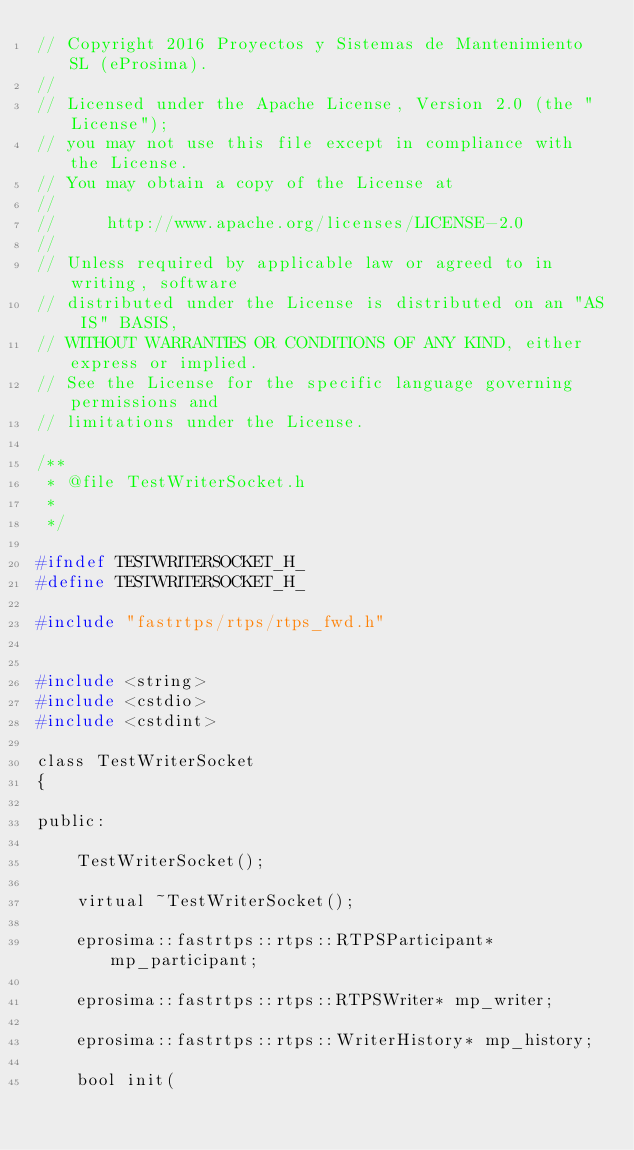<code> <loc_0><loc_0><loc_500><loc_500><_C_>// Copyright 2016 Proyectos y Sistemas de Mantenimiento SL (eProsima).
//
// Licensed under the Apache License, Version 2.0 (the "License");
// you may not use this file except in compliance with the License.
// You may obtain a copy of the License at
//
//     http://www.apache.org/licenses/LICENSE-2.0
//
// Unless required by applicable law or agreed to in writing, software
// distributed under the License is distributed on an "AS IS" BASIS,
// WITHOUT WARRANTIES OR CONDITIONS OF ANY KIND, either express or implied.
// See the License for the specific language governing permissions and
// limitations under the License.

/**
 * @file TestWriterSocket.h
 *
 */

#ifndef TESTWRITERSOCKET_H_
#define TESTWRITERSOCKET_H_

#include "fastrtps/rtps/rtps_fwd.h"


#include <string>
#include <cstdio>
#include <cstdint>

class TestWriterSocket
{

public:

    TestWriterSocket();

    virtual ~TestWriterSocket();

    eprosima::fastrtps::rtps::RTPSParticipant* mp_participant;

    eprosima::fastrtps::rtps::RTPSWriter* mp_writer;

    eprosima::fastrtps::rtps::WriterHistory* mp_history;

    bool init(</code> 